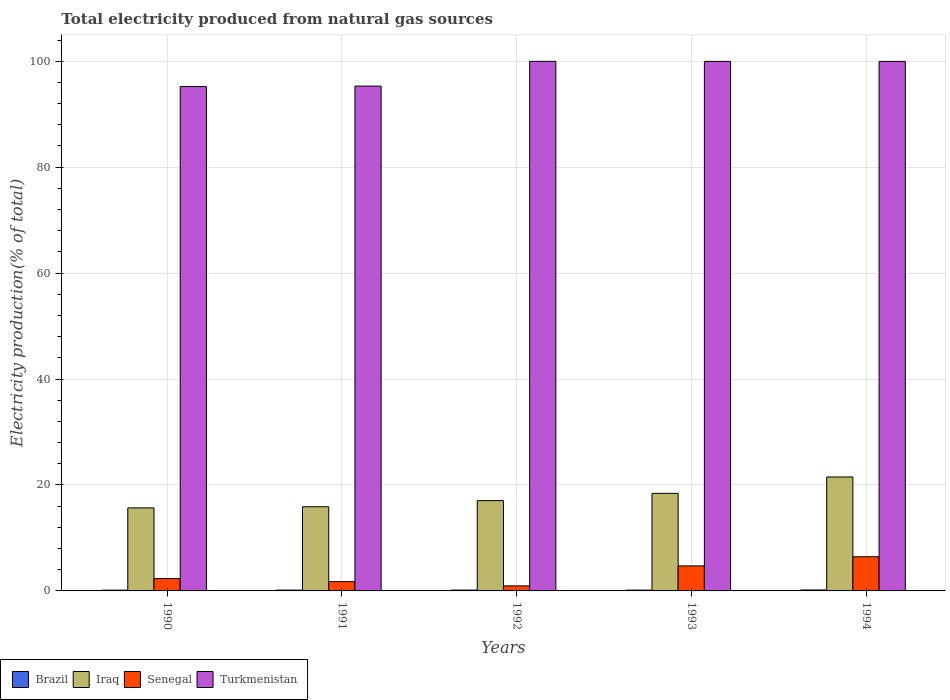How many groups of bars are there?
Offer a terse response. 5. How many bars are there on the 2nd tick from the right?
Your answer should be very brief. 4. In how many cases, is the number of bars for a given year not equal to the number of legend labels?
Your answer should be compact. 0. What is the total electricity produced in Turkmenistan in 1994?
Offer a terse response. 99.96. Across all years, what is the maximum total electricity produced in Iraq?
Your answer should be compact. 21.51. Across all years, what is the minimum total electricity produced in Senegal?
Keep it short and to the point. 0.95. In which year was the total electricity produced in Turkmenistan minimum?
Make the answer very short. 1990. What is the total total electricity produced in Iraq in the graph?
Make the answer very short. 88.54. What is the difference between the total electricity produced in Senegal in 1992 and that in 1993?
Offer a terse response. -3.77. What is the difference between the total electricity produced in Turkmenistan in 1993 and the total electricity produced in Brazil in 1994?
Your answer should be compact. 99.78. What is the average total electricity produced in Iraq per year?
Give a very brief answer. 17.71. In the year 1993, what is the difference between the total electricity produced in Iraq and total electricity produced in Senegal?
Provide a short and direct response. 13.7. In how many years, is the total electricity produced in Senegal greater than 20 %?
Give a very brief answer. 0. What is the ratio of the total electricity produced in Senegal in 1993 to that in 1994?
Your response must be concise. 0.73. Is the total electricity produced in Senegal in 1990 less than that in 1992?
Ensure brevity in your answer.  No. Is the difference between the total electricity produced in Iraq in 1992 and 1994 greater than the difference between the total electricity produced in Senegal in 1992 and 1994?
Give a very brief answer. Yes. What is the difference between the highest and the second highest total electricity produced in Iraq?
Your answer should be very brief. 3.09. What is the difference between the highest and the lowest total electricity produced in Brazil?
Provide a short and direct response. 0.04. Is the sum of the total electricity produced in Iraq in 1990 and 1993 greater than the maximum total electricity produced in Senegal across all years?
Your response must be concise. Yes. Is it the case that in every year, the sum of the total electricity produced in Iraq and total electricity produced in Turkmenistan is greater than the sum of total electricity produced in Brazil and total electricity produced in Senegal?
Give a very brief answer. Yes. What does the 3rd bar from the left in 1990 represents?
Keep it short and to the point. Senegal. What does the 2nd bar from the right in 1990 represents?
Make the answer very short. Senegal. Is it the case that in every year, the sum of the total electricity produced in Iraq and total electricity produced in Senegal is greater than the total electricity produced in Turkmenistan?
Ensure brevity in your answer.  No. Are all the bars in the graph horizontal?
Your answer should be compact. No. How many years are there in the graph?
Your answer should be very brief. 5. Does the graph contain any zero values?
Your answer should be compact. No. How are the legend labels stacked?
Give a very brief answer. Horizontal. What is the title of the graph?
Provide a succinct answer. Total electricity produced from natural gas sources. Does "Botswana" appear as one of the legend labels in the graph?
Keep it short and to the point. No. What is the label or title of the Y-axis?
Provide a short and direct response. Electricity production(% of total). What is the Electricity production(% of total) of Brazil in 1990?
Offer a very short reply. 0.15. What is the Electricity production(% of total) of Iraq in 1990?
Your answer should be compact. 15.68. What is the Electricity production(% of total) in Senegal in 1990?
Offer a terse response. 2.33. What is the Electricity production(% of total) of Turkmenistan in 1990?
Give a very brief answer. 95.21. What is the Electricity production(% of total) in Brazil in 1991?
Offer a very short reply. 0.16. What is the Electricity production(% of total) in Iraq in 1991?
Provide a short and direct response. 15.89. What is the Electricity production(% of total) of Senegal in 1991?
Your answer should be compact. 1.75. What is the Electricity production(% of total) of Turkmenistan in 1991?
Give a very brief answer. 95.3. What is the Electricity production(% of total) in Brazil in 1992?
Your answer should be very brief. 0.16. What is the Electricity production(% of total) of Iraq in 1992?
Your answer should be compact. 17.05. What is the Electricity production(% of total) of Senegal in 1992?
Keep it short and to the point. 0.95. What is the Electricity production(% of total) in Turkmenistan in 1992?
Make the answer very short. 99.97. What is the Electricity production(% of total) of Brazil in 1993?
Ensure brevity in your answer.  0.15. What is the Electricity production(% of total) in Iraq in 1993?
Provide a succinct answer. 18.42. What is the Electricity production(% of total) of Senegal in 1993?
Provide a short and direct response. 4.73. What is the Electricity production(% of total) in Turkmenistan in 1993?
Ensure brevity in your answer.  99.96. What is the Electricity production(% of total) in Brazil in 1994?
Provide a succinct answer. 0.18. What is the Electricity production(% of total) in Iraq in 1994?
Provide a succinct answer. 21.51. What is the Electricity production(% of total) in Senegal in 1994?
Your answer should be very brief. 6.45. What is the Electricity production(% of total) of Turkmenistan in 1994?
Offer a terse response. 99.96. Across all years, what is the maximum Electricity production(% of total) of Brazil?
Ensure brevity in your answer.  0.18. Across all years, what is the maximum Electricity production(% of total) in Iraq?
Your response must be concise. 21.51. Across all years, what is the maximum Electricity production(% of total) of Senegal?
Keep it short and to the point. 6.45. Across all years, what is the maximum Electricity production(% of total) of Turkmenistan?
Provide a short and direct response. 99.97. Across all years, what is the minimum Electricity production(% of total) of Brazil?
Keep it short and to the point. 0.15. Across all years, what is the minimum Electricity production(% of total) of Iraq?
Your answer should be very brief. 15.68. Across all years, what is the minimum Electricity production(% of total) of Senegal?
Make the answer very short. 0.95. Across all years, what is the minimum Electricity production(% of total) in Turkmenistan?
Provide a short and direct response. 95.21. What is the total Electricity production(% of total) of Brazil in the graph?
Your answer should be very brief. 0.81. What is the total Electricity production(% of total) in Iraq in the graph?
Ensure brevity in your answer.  88.54. What is the total Electricity production(% of total) of Senegal in the graph?
Offer a very short reply. 16.21. What is the total Electricity production(% of total) of Turkmenistan in the graph?
Ensure brevity in your answer.  490.4. What is the difference between the Electricity production(% of total) in Brazil in 1990 and that in 1991?
Your answer should be compact. -0.01. What is the difference between the Electricity production(% of total) in Iraq in 1990 and that in 1991?
Give a very brief answer. -0.21. What is the difference between the Electricity production(% of total) of Senegal in 1990 and that in 1991?
Offer a very short reply. 0.57. What is the difference between the Electricity production(% of total) of Turkmenistan in 1990 and that in 1991?
Offer a very short reply. -0.09. What is the difference between the Electricity production(% of total) in Brazil in 1990 and that in 1992?
Give a very brief answer. -0.01. What is the difference between the Electricity production(% of total) in Iraq in 1990 and that in 1992?
Provide a short and direct response. -1.37. What is the difference between the Electricity production(% of total) of Senegal in 1990 and that in 1992?
Give a very brief answer. 1.38. What is the difference between the Electricity production(% of total) of Turkmenistan in 1990 and that in 1992?
Offer a terse response. -4.76. What is the difference between the Electricity production(% of total) of Brazil in 1990 and that in 1993?
Provide a succinct answer. -0.01. What is the difference between the Electricity production(% of total) in Iraq in 1990 and that in 1993?
Make the answer very short. -2.75. What is the difference between the Electricity production(% of total) of Senegal in 1990 and that in 1993?
Offer a very short reply. -2.4. What is the difference between the Electricity production(% of total) in Turkmenistan in 1990 and that in 1993?
Offer a terse response. -4.75. What is the difference between the Electricity production(% of total) of Brazil in 1990 and that in 1994?
Give a very brief answer. -0.04. What is the difference between the Electricity production(% of total) of Iraq in 1990 and that in 1994?
Provide a succinct answer. -5.84. What is the difference between the Electricity production(% of total) in Senegal in 1990 and that in 1994?
Keep it short and to the point. -4.12. What is the difference between the Electricity production(% of total) of Turkmenistan in 1990 and that in 1994?
Keep it short and to the point. -4.75. What is the difference between the Electricity production(% of total) of Brazil in 1991 and that in 1992?
Make the answer very short. -0. What is the difference between the Electricity production(% of total) in Iraq in 1991 and that in 1992?
Your answer should be very brief. -1.16. What is the difference between the Electricity production(% of total) of Senegal in 1991 and that in 1992?
Provide a short and direct response. 0.8. What is the difference between the Electricity production(% of total) in Turkmenistan in 1991 and that in 1992?
Provide a succinct answer. -4.67. What is the difference between the Electricity production(% of total) of Brazil in 1991 and that in 1993?
Offer a very short reply. 0.01. What is the difference between the Electricity production(% of total) in Iraq in 1991 and that in 1993?
Your answer should be compact. -2.54. What is the difference between the Electricity production(% of total) in Senegal in 1991 and that in 1993?
Offer a terse response. -2.97. What is the difference between the Electricity production(% of total) in Turkmenistan in 1991 and that in 1993?
Provide a succinct answer. -4.66. What is the difference between the Electricity production(% of total) in Brazil in 1991 and that in 1994?
Your answer should be compact. -0.03. What is the difference between the Electricity production(% of total) in Iraq in 1991 and that in 1994?
Offer a terse response. -5.62. What is the difference between the Electricity production(% of total) in Senegal in 1991 and that in 1994?
Your response must be concise. -4.69. What is the difference between the Electricity production(% of total) in Turkmenistan in 1991 and that in 1994?
Offer a very short reply. -4.66. What is the difference between the Electricity production(% of total) in Brazil in 1992 and that in 1993?
Keep it short and to the point. 0.01. What is the difference between the Electricity production(% of total) of Iraq in 1992 and that in 1993?
Provide a short and direct response. -1.37. What is the difference between the Electricity production(% of total) of Senegal in 1992 and that in 1993?
Give a very brief answer. -3.77. What is the difference between the Electricity production(% of total) in Turkmenistan in 1992 and that in 1993?
Provide a succinct answer. 0.01. What is the difference between the Electricity production(% of total) of Brazil in 1992 and that in 1994?
Offer a very short reply. -0.02. What is the difference between the Electricity production(% of total) in Iraq in 1992 and that in 1994?
Your answer should be compact. -4.46. What is the difference between the Electricity production(% of total) in Senegal in 1992 and that in 1994?
Keep it short and to the point. -5.5. What is the difference between the Electricity production(% of total) in Turkmenistan in 1992 and that in 1994?
Ensure brevity in your answer.  0.01. What is the difference between the Electricity production(% of total) of Brazil in 1993 and that in 1994?
Your answer should be very brief. -0.03. What is the difference between the Electricity production(% of total) of Iraq in 1993 and that in 1994?
Offer a very short reply. -3.09. What is the difference between the Electricity production(% of total) of Senegal in 1993 and that in 1994?
Give a very brief answer. -1.72. What is the difference between the Electricity production(% of total) in Turkmenistan in 1993 and that in 1994?
Ensure brevity in your answer.  -0. What is the difference between the Electricity production(% of total) of Brazil in 1990 and the Electricity production(% of total) of Iraq in 1991?
Give a very brief answer. -15.74. What is the difference between the Electricity production(% of total) of Brazil in 1990 and the Electricity production(% of total) of Senegal in 1991?
Provide a succinct answer. -1.61. What is the difference between the Electricity production(% of total) of Brazil in 1990 and the Electricity production(% of total) of Turkmenistan in 1991?
Your answer should be very brief. -95.16. What is the difference between the Electricity production(% of total) in Iraq in 1990 and the Electricity production(% of total) in Senegal in 1991?
Keep it short and to the point. 13.92. What is the difference between the Electricity production(% of total) of Iraq in 1990 and the Electricity production(% of total) of Turkmenistan in 1991?
Your answer should be compact. -79.63. What is the difference between the Electricity production(% of total) of Senegal in 1990 and the Electricity production(% of total) of Turkmenistan in 1991?
Your response must be concise. -92.97. What is the difference between the Electricity production(% of total) in Brazil in 1990 and the Electricity production(% of total) in Iraq in 1992?
Your answer should be compact. -16.9. What is the difference between the Electricity production(% of total) in Brazil in 1990 and the Electricity production(% of total) in Senegal in 1992?
Offer a terse response. -0.8. What is the difference between the Electricity production(% of total) in Brazil in 1990 and the Electricity production(% of total) in Turkmenistan in 1992?
Your answer should be very brief. -99.82. What is the difference between the Electricity production(% of total) of Iraq in 1990 and the Electricity production(% of total) of Senegal in 1992?
Provide a short and direct response. 14.72. What is the difference between the Electricity production(% of total) of Iraq in 1990 and the Electricity production(% of total) of Turkmenistan in 1992?
Your answer should be compact. -84.29. What is the difference between the Electricity production(% of total) of Senegal in 1990 and the Electricity production(% of total) of Turkmenistan in 1992?
Ensure brevity in your answer.  -97.64. What is the difference between the Electricity production(% of total) of Brazil in 1990 and the Electricity production(% of total) of Iraq in 1993?
Give a very brief answer. -18.28. What is the difference between the Electricity production(% of total) in Brazil in 1990 and the Electricity production(% of total) in Senegal in 1993?
Make the answer very short. -4.58. What is the difference between the Electricity production(% of total) in Brazil in 1990 and the Electricity production(% of total) in Turkmenistan in 1993?
Your answer should be very brief. -99.81. What is the difference between the Electricity production(% of total) of Iraq in 1990 and the Electricity production(% of total) of Senegal in 1993?
Your answer should be compact. 10.95. What is the difference between the Electricity production(% of total) of Iraq in 1990 and the Electricity production(% of total) of Turkmenistan in 1993?
Your response must be concise. -84.29. What is the difference between the Electricity production(% of total) in Senegal in 1990 and the Electricity production(% of total) in Turkmenistan in 1993?
Keep it short and to the point. -97.63. What is the difference between the Electricity production(% of total) in Brazil in 1990 and the Electricity production(% of total) in Iraq in 1994?
Give a very brief answer. -21.36. What is the difference between the Electricity production(% of total) of Brazil in 1990 and the Electricity production(% of total) of Senegal in 1994?
Your response must be concise. -6.3. What is the difference between the Electricity production(% of total) in Brazil in 1990 and the Electricity production(% of total) in Turkmenistan in 1994?
Your response must be concise. -99.82. What is the difference between the Electricity production(% of total) in Iraq in 1990 and the Electricity production(% of total) in Senegal in 1994?
Your response must be concise. 9.23. What is the difference between the Electricity production(% of total) in Iraq in 1990 and the Electricity production(% of total) in Turkmenistan in 1994?
Provide a succinct answer. -84.29. What is the difference between the Electricity production(% of total) of Senegal in 1990 and the Electricity production(% of total) of Turkmenistan in 1994?
Your answer should be compact. -97.63. What is the difference between the Electricity production(% of total) in Brazil in 1991 and the Electricity production(% of total) in Iraq in 1992?
Give a very brief answer. -16.89. What is the difference between the Electricity production(% of total) in Brazil in 1991 and the Electricity production(% of total) in Senegal in 1992?
Provide a short and direct response. -0.79. What is the difference between the Electricity production(% of total) of Brazil in 1991 and the Electricity production(% of total) of Turkmenistan in 1992?
Your answer should be very brief. -99.81. What is the difference between the Electricity production(% of total) of Iraq in 1991 and the Electricity production(% of total) of Senegal in 1992?
Keep it short and to the point. 14.94. What is the difference between the Electricity production(% of total) of Iraq in 1991 and the Electricity production(% of total) of Turkmenistan in 1992?
Your answer should be very brief. -84.08. What is the difference between the Electricity production(% of total) of Senegal in 1991 and the Electricity production(% of total) of Turkmenistan in 1992?
Your response must be concise. -98.22. What is the difference between the Electricity production(% of total) in Brazil in 1991 and the Electricity production(% of total) in Iraq in 1993?
Your answer should be compact. -18.26. What is the difference between the Electricity production(% of total) of Brazil in 1991 and the Electricity production(% of total) of Senegal in 1993?
Your answer should be compact. -4.57. What is the difference between the Electricity production(% of total) of Brazil in 1991 and the Electricity production(% of total) of Turkmenistan in 1993?
Ensure brevity in your answer.  -99.8. What is the difference between the Electricity production(% of total) in Iraq in 1991 and the Electricity production(% of total) in Senegal in 1993?
Offer a very short reply. 11.16. What is the difference between the Electricity production(% of total) in Iraq in 1991 and the Electricity production(% of total) in Turkmenistan in 1993?
Provide a succinct answer. -84.07. What is the difference between the Electricity production(% of total) of Senegal in 1991 and the Electricity production(% of total) of Turkmenistan in 1993?
Provide a succinct answer. -98.21. What is the difference between the Electricity production(% of total) in Brazil in 1991 and the Electricity production(% of total) in Iraq in 1994?
Offer a terse response. -21.35. What is the difference between the Electricity production(% of total) in Brazil in 1991 and the Electricity production(% of total) in Senegal in 1994?
Provide a short and direct response. -6.29. What is the difference between the Electricity production(% of total) of Brazil in 1991 and the Electricity production(% of total) of Turkmenistan in 1994?
Your answer should be very brief. -99.8. What is the difference between the Electricity production(% of total) of Iraq in 1991 and the Electricity production(% of total) of Senegal in 1994?
Keep it short and to the point. 9.44. What is the difference between the Electricity production(% of total) of Iraq in 1991 and the Electricity production(% of total) of Turkmenistan in 1994?
Ensure brevity in your answer.  -84.08. What is the difference between the Electricity production(% of total) in Senegal in 1991 and the Electricity production(% of total) in Turkmenistan in 1994?
Your answer should be compact. -98.21. What is the difference between the Electricity production(% of total) of Brazil in 1992 and the Electricity production(% of total) of Iraq in 1993?
Offer a terse response. -18.26. What is the difference between the Electricity production(% of total) of Brazil in 1992 and the Electricity production(% of total) of Senegal in 1993?
Make the answer very short. -4.56. What is the difference between the Electricity production(% of total) of Brazil in 1992 and the Electricity production(% of total) of Turkmenistan in 1993?
Your response must be concise. -99.8. What is the difference between the Electricity production(% of total) of Iraq in 1992 and the Electricity production(% of total) of Senegal in 1993?
Make the answer very short. 12.32. What is the difference between the Electricity production(% of total) of Iraq in 1992 and the Electricity production(% of total) of Turkmenistan in 1993?
Provide a short and direct response. -82.91. What is the difference between the Electricity production(% of total) of Senegal in 1992 and the Electricity production(% of total) of Turkmenistan in 1993?
Your response must be concise. -99.01. What is the difference between the Electricity production(% of total) of Brazil in 1992 and the Electricity production(% of total) of Iraq in 1994?
Give a very brief answer. -21.35. What is the difference between the Electricity production(% of total) in Brazil in 1992 and the Electricity production(% of total) in Senegal in 1994?
Provide a succinct answer. -6.29. What is the difference between the Electricity production(% of total) in Brazil in 1992 and the Electricity production(% of total) in Turkmenistan in 1994?
Offer a very short reply. -99.8. What is the difference between the Electricity production(% of total) in Iraq in 1992 and the Electricity production(% of total) in Senegal in 1994?
Offer a very short reply. 10.6. What is the difference between the Electricity production(% of total) of Iraq in 1992 and the Electricity production(% of total) of Turkmenistan in 1994?
Your answer should be compact. -82.91. What is the difference between the Electricity production(% of total) of Senegal in 1992 and the Electricity production(% of total) of Turkmenistan in 1994?
Your response must be concise. -99.01. What is the difference between the Electricity production(% of total) in Brazil in 1993 and the Electricity production(% of total) in Iraq in 1994?
Your response must be concise. -21.36. What is the difference between the Electricity production(% of total) in Brazil in 1993 and the Electricity production(% of total) in Senegal in 1994?
Your answer should be compact. -6.29. What is the difference between the Electricity production(% of total) in Brazil in 1993 and the Electricity production(% of total) in Turkmenistan in 1994?
Provide a short and direct response. -99.81. What is the difference between the Electricity production(% of total) in Iraq in 1993 and the Electricity production(% of total) in Senegal in 1994?
Provide a short and direct response. 11.97. What is the difference between the Electricity production(% of total) in Iraq in 1993 and the Electricity production(% of total) in Turkmenistan in 1994?
Your answer should be very brief. -81.54. What is the difference between the Electricity production(% of total) in Senegal in 1993 and the Electricity production(% of total) in Turkmenistan in 1994?
Provide a succinct answer. -95.24. What is the average Electricity production(% of total) in Brazil per year?
Offer a very short reply. 0.16. What is the average Electricity production(% of total) in Iraq per year?
Provide a short and direct response. 17.71. What is the average Electricity production(% of total) in Senegal per year?
Give a very brief answer. 3.24. What is the average Electricity production(% of total) in Turkmenistan per year?
Your answer should be very brief. 98.08. In the year 1990, what is the difference between the Electricity production(% of total) of Brazil and Electricity production(% of total) of Iraq?
Keep it short and to the point. -15.53. In the year 1990, what is the difference between the Electricity production(% of total) of Brazil and Electricity production(% of total) of Senegal?
Provide a succinct answer. -2.18. In the year 1990, what is the difference between the Electricity production(% of total) in Brazil and Electricity production(% of total) in Turkmenistan?
Provide a succinct answer. -95.06. In the year 1990, what is the difference between the Electricity production(% of total) of Iraq and Electricity production(% of total) of Senegal?
Your response must be concise. 13.35. In the year 1990, what is the difference between the Electricity production(% of total) in Iraq and Electricity production(% of total) in Turkmenistan?
Offer a very short reply. -79.53. In the year 1990, what is the difference between the Electricity production(% of total) in Senegal and Electricity production(% of total) in Turkmenistan?
Your answer should be very brief. -92.88. In the year 1991, what is the difference between the Electricity production(% of total) in Brazil and Electricity production(% of total) in Iraq?
Make the answer very short. -15.73. In the year 1991, what is the difference between the Electricity production(% of total) in Brazil and Electricity production(% of total) in Senegal?
Give a very brief answer. -1.6. In the year 1991, what is the difference between the Electricity production(% of total) in Brazil and Electricity production(% of total) in Turkmenistan?
Keep it short and to the point. -95.14. In the year 1991, what is the difference between the Electricity production(% of total) in Iraq and Electricity production(% of total) in Senegal?
Your answer should be very brief. 14.13. In the year 1991, what is the difference between the Electricity production(% of total) of Iraq and Electricity production(% of total) of Turkmenistan?
Your answer should be very brief. -79.42. In the year 1991, what is the difference between the Electricity production(% of total) in Senegal and Electricity production(% of total) in Turkmenistan?
Make the answer very short. -93.55. In the year 1992, what is the difference between the Electricity production(% of total) in Brazil and Electricity production(% of total) in Iraq?
Your response must be concise. -16.89. In the year 1992, what is the difference between the Electricity production(% of total) in Brazil and Electricity production(% of total) in Senegal?
Your response must be concise. -0.79. In the year 1992, what is the difference between the Electricity production(% of total) of Brazil and Electricity production(% of total) of Turkmenistan?
Your response must be concise. -99.81. In the year 1992, what is the difference between the Electricity production(% of total) in Iraq and Electricity production(% of total) in Senegal?
Offer a very short reply. 16.1. In the year 1992, what is the difference between the Electricity production(% of total) of Iraq and Electricity production(% of total) of Turkmenistan?
Provide a succinct answer. -82.92. In the year 1992, what is the difference between the Electricity production(% of total) in Senegal and Electricity production(% of total) in Turkmenistan?
Keep it short and to the point. -99.02. In the year 1993, what is the difference between the Electricity production(% of total) of Brazil and Electricity production(% of total) of Iraq?
Provide a succinct answer. -18.27. In the year 1993, what is the difference between the Electricity production(% of total) of Brazil and Electricity production(% of total) of Senegal?
Offer a terse response. -4.57. In the year 1993, what is the difference between the Electricity production(% of total) of Brazil and Electricity production(% of total) of Turkmenistan?
Make the answer very short. -99.81. In the year 1993, what is the difference between the Electricity production(% of total) in Iraq and Electricity production(% of total) in Senegal?
Offer a terse response. 13.7. In the year 1993, what is the difference between the Electricity production(% of total) of Iraq and Electricity production(% of total) of Turkmenistan?
Your response must be concise. -81.54. In the year 1993, what is the difference between the Electricity production(% of total) of Senegal and Electricity production(% of total) of Turkmenistan?
Provide a short and direct response. -95.24. In the year 1994, what is the difference between the Electricity production(% of total) in Brazil and Electricity production(% of total) in Iraq?
Give a very brief answer. -21.33. In the year 1994, what is the difference between the Electricity production(% of total) of Brazil and Electricity production(% of total) of Senegal?
Make the answer very short. -6.26. In the year 1994, what is the difference between the Electricity production(% of total) in Brazil and Electricity production(% of total) in Turkmenistan?
Provide a short and direct response. -99.78. In the year 1994, what is the difference between the Electricity production(% of total) in Iraq and Electricity production(% of total) in Senegal?
Offer a very short reply. 15.06. In the year 1994, what is the difference between the Electricity production(% of total) in Iraq and Electricity production(% of total) in Turkmenistan?
Provide a short and direct response. -78.45. In the year 1994, what is the difference between the Electricity production(% of total) of Senegal and Electricity production(% of total) of Turkmenistan?
Give a very brief answer. -93.51. What is the ratio of the Electricity production(% of total) of Brazil in 1990 to that in 1991?
Your response must be concise. 0.92. What is the ratio of the Electricity production(% of total) in Iraq in 1990 to that in 1991?
Offer a very short reply. 0.99. What is the ratio of the Electricity production(% of total) in Senegal in 1990 to that in 1991?
Your answer should be compact. 1.33. What is the ratio of the Electricity production(% of total) in Brazil in 1990 to that in 1992?
Keep it short and to the point. 0.91. What is the ratio of the Electricity production(% of total) in Iraq in 1990 to that in 1992?
Offer a very short reply. 0.92. What is the ratio of the Electricity production(% of total) in Senegal in 1990 to that in 1992?
Provide a short and direct response. 2.45. What is the ratio of the Electricity production(% of total) in Brazil in 1990 to that in 1993?
Offer a terse response. 0.95. What is the ratio of the Electricity production(% of total) of Iraq in 1990 to that in 1993?
Give a very brief answer. 0.85. What is the ratio of the Electricity production(% of total) in Senegal in 1990 to that in 1993?
Give a very brief answer. 0.49. What is the ratio of the Electricity production(% of total) in Turkmenistan in 1990 to that in 1993?
Your answer should be very brief. 0.95. What is the ratio of the Electricity production(% of total) of Brazil in 1990 to that in 1994?
Provide a succinct answer. 0.79. What is the ratio of the Electricity production(% of total) of Iraq in 1990 to that in 1994?
Keep it short and to the point. 0.73. What is the ratio of the Electricity production(% of total) of Senegal in 1990 to that in 1994?
Provide a succinct answer. 0.36. What is the ratio of the Electricity production(% of total) in Turkmenistan in 1990 to that in 1994?
Your response must be concise. 0.95. What is the ratio of the Electricity production(% of total) in Brazil in 1991 to that in 1992?
Ensure brevity in your answer.  0.99. What is the ratio of the Electricity production(% of total) in Iraq in 1991 to that in 1992?
Offer a very short reply. 0.93. What is the ratio of the Electricity production(% of total) in Senegal in 1991 to that in 1992?
Provide a succinct answer. 1.85. What is the ratio of the Electricity production(% of total) of Turkmenistan in 1991 to that in 1992?
Provide a short and direct response. 0.95. What is the ratio of the Electricity production(% of total) in Brazil in 1991 to that in 1993?
Provide a short and direct response. 1.03. What is the ratio of the Electricity production(% of total) of Iraq in 1991 to that in 1993?
Provide a succinct answer. 0.86. What is the ratio of the Electricity production(% of total) in Senegal in 1991 to that in 1993?
Offer a very short reply. 0.37. What is the ratio of the Electricity production(% of total) of Turkmenistan in 1991 to that in 1993?
Offer a terse response. 0.95. What is the ratio of the Electricity production(% of total) in Brazil in 1991 to that in 1994?
Ensure brevity in your answer.  0.86. What is the ratio of the Electricity production(% of total) of Iraq in 1991 to that in 1994?
Make the answer very short. 0.74. What is the ratio of the Electricity production(% of total) of Senegal in 1991 to that in 1994?
Provide a short and direct response. 0.27. What is the ratio of the Electricity production(% of total) in Turkmenistan in 1991 to that in 1994?
Your answer should be very brief. 0.95. What is the ratio of the Electricity production(% of total) in Brazil in 1992 to that in 1993?
Provide a succinct answer. 1.05. What is the ratio of the Electricity production(% of total) in Iraq in 1992 to that in 1993?
Offer a very short reply. 0.93. What is the ratio of the Electricity production(% of total) of Senegal in 1992 to that in 1993?
Your answer should be compact. 0.2. What is the ratio of the Electricity production(% of total) in Turkmenistan in 1992 to that in 1993?
Ensure brevity in your answer.  1. What is the ratio of the Electricity production(% of total) in Brazil in 1992 to that in 1994?
Provide a succinct answer. 0.88. What is the ratio of the Electricity production(% of total) in Iraq in 1992 to that in 1994?
Your answer should be compact. 0.79. What is the ratio of the Electricity production(% of total) in Senegal in 1992 to that in 1994?
Ensure brevity in your answer.  0.15. What is the ratio of the Electricity production(% of total) of Brazil in 1993 to that in 1994?
Your response must be concise. 0.84. What is the ratio of the Electricity production(% of total) of Iraq in 1993 to that in 1994?
Your response must be concise. 0.86. What is the ratio of the Electricity production(% of total) of Senegal in 1993 to that in 1994?
Your answer should be very brief. 0.73. What is the difference between the highest and the second highest Electricity production(% of total) of Brazil?
Keep it short and to the point. 0.02. What is the difference between the highest and the second highest Electricity production(% of total) in Iraq?
Your answer should be compact. 3.09. What is the difference between the highest and the second highest Electricity production(% of total) in Senegal?
Provide a short and direct response. 1.72. What is the difference between the highest and the second highest Electricity production(% of total) of Turkmenistan?
Your answer should be very brief. 0.01. What is the difference between the highest and the lowest Electricity production(% of total) of Brazil?
Offer a very short reply. 0.04. What is the difference between the highest and the lowest Electricity production(% of total) of Iraq?
Give a very brief answer. 5.84. What is the difference between the highest and the lowest Electricity production(% of total) in Senegal?
Offer a terse response. 5.5. What is the difference between the highest and the lowest Electricity production(% of total) of Turkmenistan?
Ensure brevity in your answer.  4.76. 